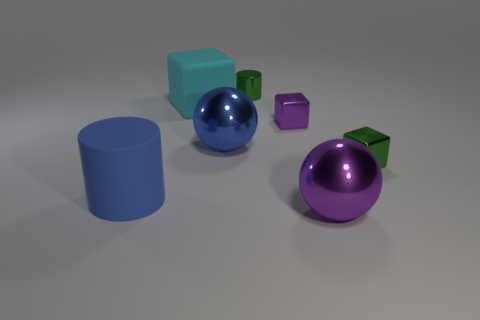Is there any other thing that has the same size as the blue ball?
Make the answer very short. Yes. Is the big cylinder the same color as the big cube?
Make the answer very short. No. Is the number of shiny spheres greater than the number of big red things?
Ensure brevity in your answer.  Yes. How many other things are there of the same color as the matte cube?
Ensure brevity in your answer.  0. There is a big shiny thing to the left of the large purple sphere; what number of large purple metal objects are in front of it?
Ensure brevity in your answer.  1. There is a green cylinder; are there any big blue things behind it?
Make the answer very short. No. There is a big cyan rubber thing left of the cylinder that is behind the big blue metallic thing; what shape is it?
Your response must be concise. Cube. Are there fewer large blocks that are in front of the tiny purple metal thing than big matte blocks that are left of the large matte cylinder?
Offer a very short reply. No. What is the color of the other large metallic object that is the same shape as the blue shiny object?
Your answer should be compact. Purple. How many large things are behind the large cylinder and on the right side of the cyan thing?
Offer a terse response. 1. 